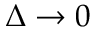Convert formula to latex. <formula><loc_0><loc_0><loc_500><loc_500>\Delta \rightarrow 0</formula> 